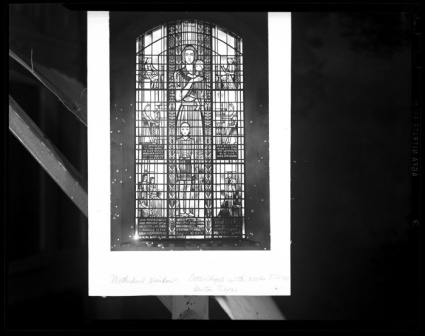What does the stained glass imagery typically represent? Stained glass windows often serve as visual stories, encapsulating religious narratives, moral lessons, or commemorating saints and significant figures in the faith. The imagery is symbolic, with each color and design element meticulously chosen to convey spiritual truths or doctrinal teachings. In addition to their didactic role, these windows are crafted to inspire awe and elevate the spirit of congregants through their interplay of light and color. 